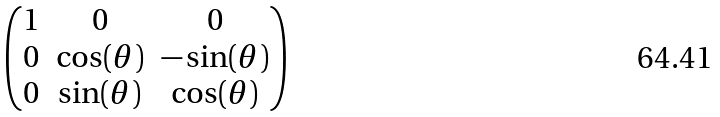<formula> <loc_0><loc_0><loc_500><loc_500>\begin{pmatrix} 1 & 0 & 0 \\ 0 & \cos ( \theta ) & - \sin ( \theta ) \\ 0 & \sin ( \theta ) & \cos ( \theta ) \end{pmatrix}</formula> 